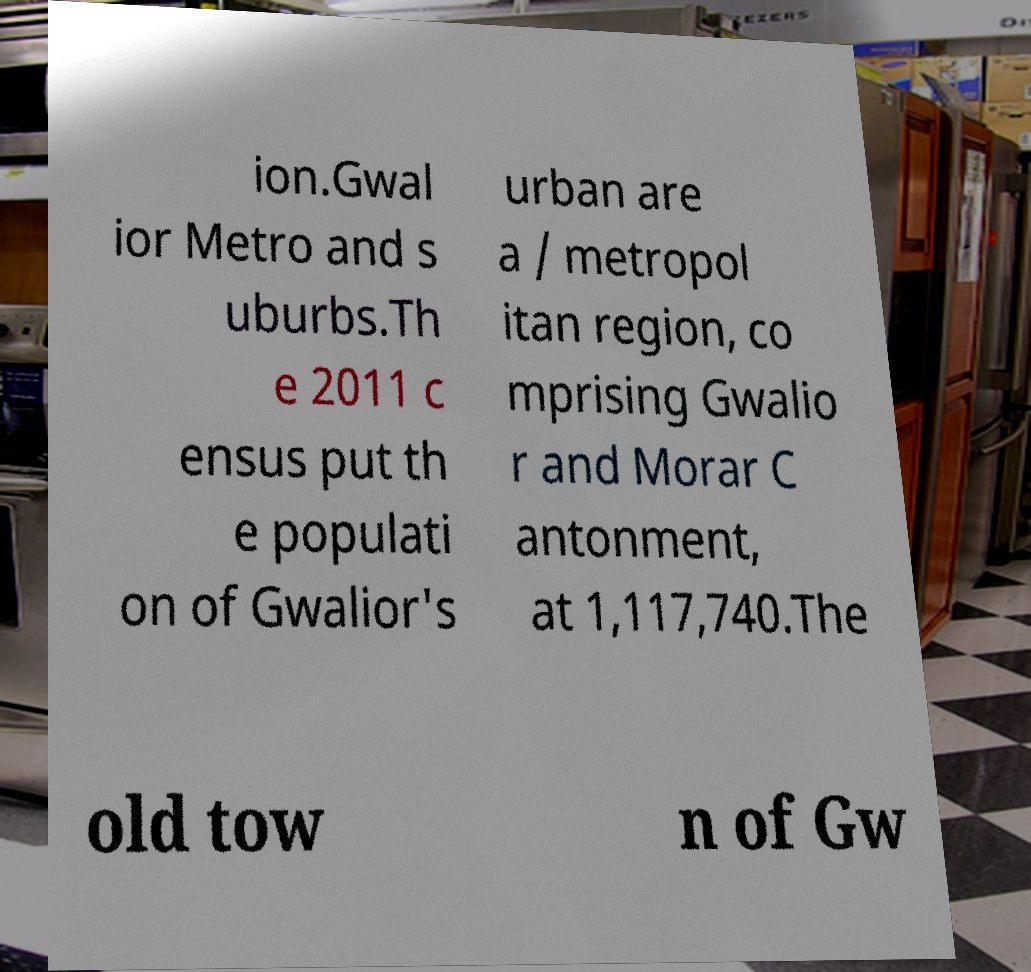Could you extract and type out the text from this image? ion.Gwal ior Metro and s uburbs.Th e 2011 c ensus put th e populati on of Gwalior's urban are a / metropol itan region, co mprising Gwalio r and Morar C antonment, at 1,117,740.The old tow n of Gw 